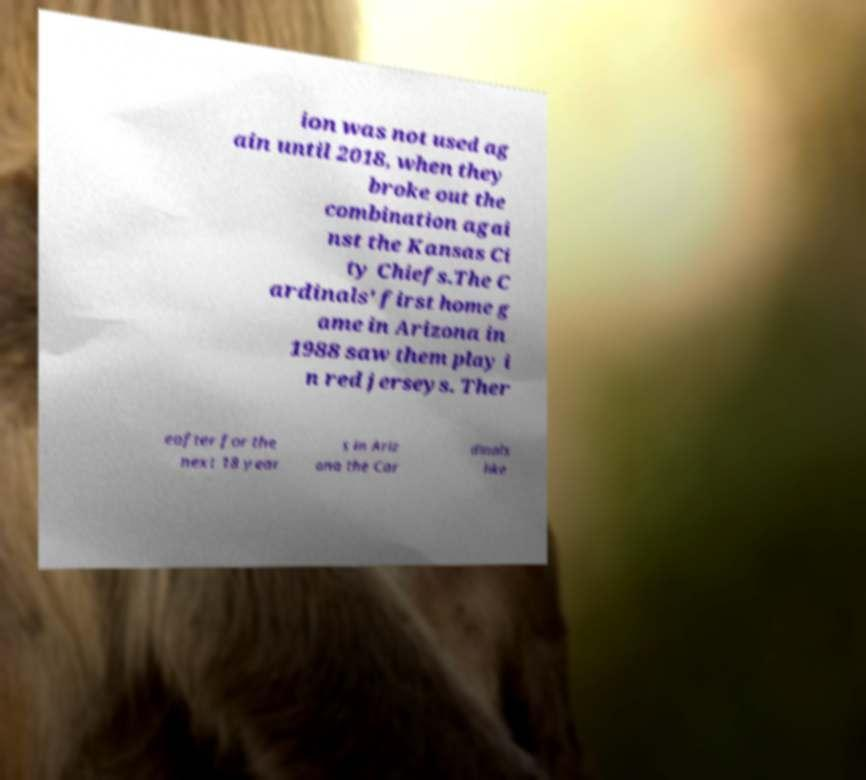For documentation purposes, I need the text within this image transcribed. Could you provide that? ion was not used ag ain until 2018, when they broke out the combination agai nst the Kansas Ci ty Chiefs.The C ardinals' first home g ame in Arizona in 1988 saw them play i n red jerseys. Ther eafter for the next 18 year s in Ariz ona the Car dinals like 